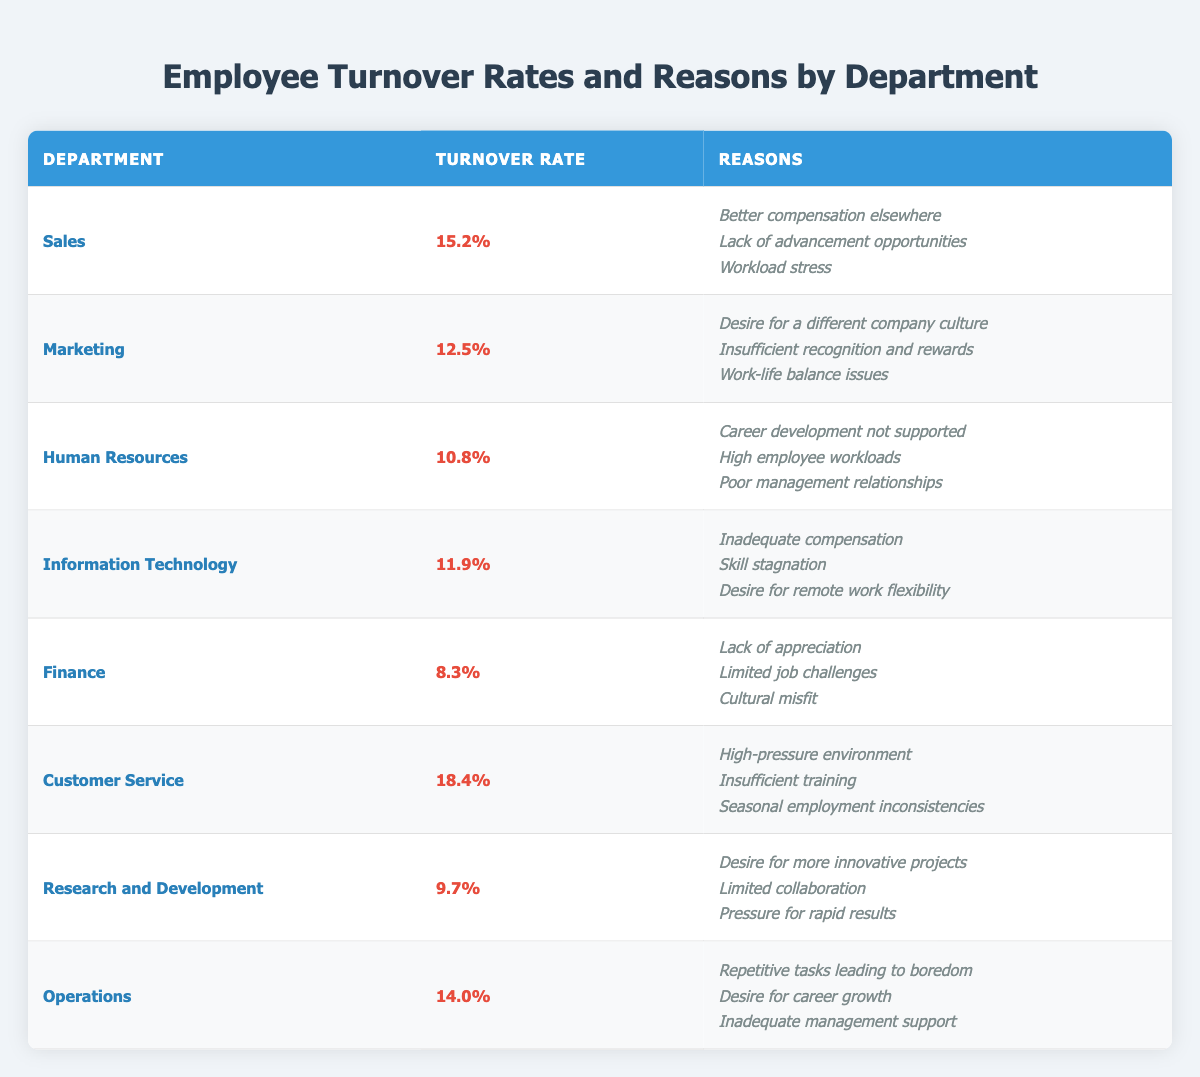What is the turnover rate for the Customer Service department? The table shows that the turnover rate for the Customer Service department is listed as 18.4%.
Answer: 18.4% Which department has the highest turnover rate? Looking at the turnover rates listed, Customer Service has the highest rate at 18.4%.
Answer: Customer Service What are the top three reasons for turnover in the Sales department? The reasons listed for the Sales department are: Better compensation elsewhere, Lack of advancement opportunities, and Workload stress.
Answer: Better compensation elsewhere, Lack of advancement opportunities, Workload stress What is the average turnover rate across all departments? To find the average, sum the turnover rates (15.2 + 12.5 + 10.8 + 11.9 + 8.3 + 18.4 + 9.7 + 14.0 = 99.8) and divide by the number of departments (8). Therefore, the average turnover rate is 99.8 / 8 = 12.475%.
Answer: 12.475% Which department has a turnover rate lower than 10%? The table shows that the Finance department has a turnover rate of 8.3%, which is lower than 10%.
Answer: Finance Are there any departments where poor management relationships are cited as a reason for turnover? Yes, the Human Resources department cites poor management relationships as a reason for turnover.
Answer: Yes What is the difference in turnover rate between Sales and Finance departments? The turnover rate for Sales is 15.2% and for Finance is 8.3%. The difference is 15.2 - 8.3 = 6.9%.
Answer: 6.9% List the reasons for turnover in the Information Technology department. The reasons for turnover listed for Information Technology are: Inadequate compensation, Skill stagnation, and Desire for remote work flexibility.
Answer: Inadequate compensation, Skill stagnation, Desire for remote work flexibility Is there a department where a lack of appreciation is mentioned as a reason for turnover? Yes, the Finance department mentions lack of appreciation as one of the reasons for turnover.
Answer: Yes How many departments report a desire for career growth as a reason for turnover? The Operations department mentions a desire for career growth, and it is the only one from the data provided. Therefore, only one department reports this reason.
Answer: 1 